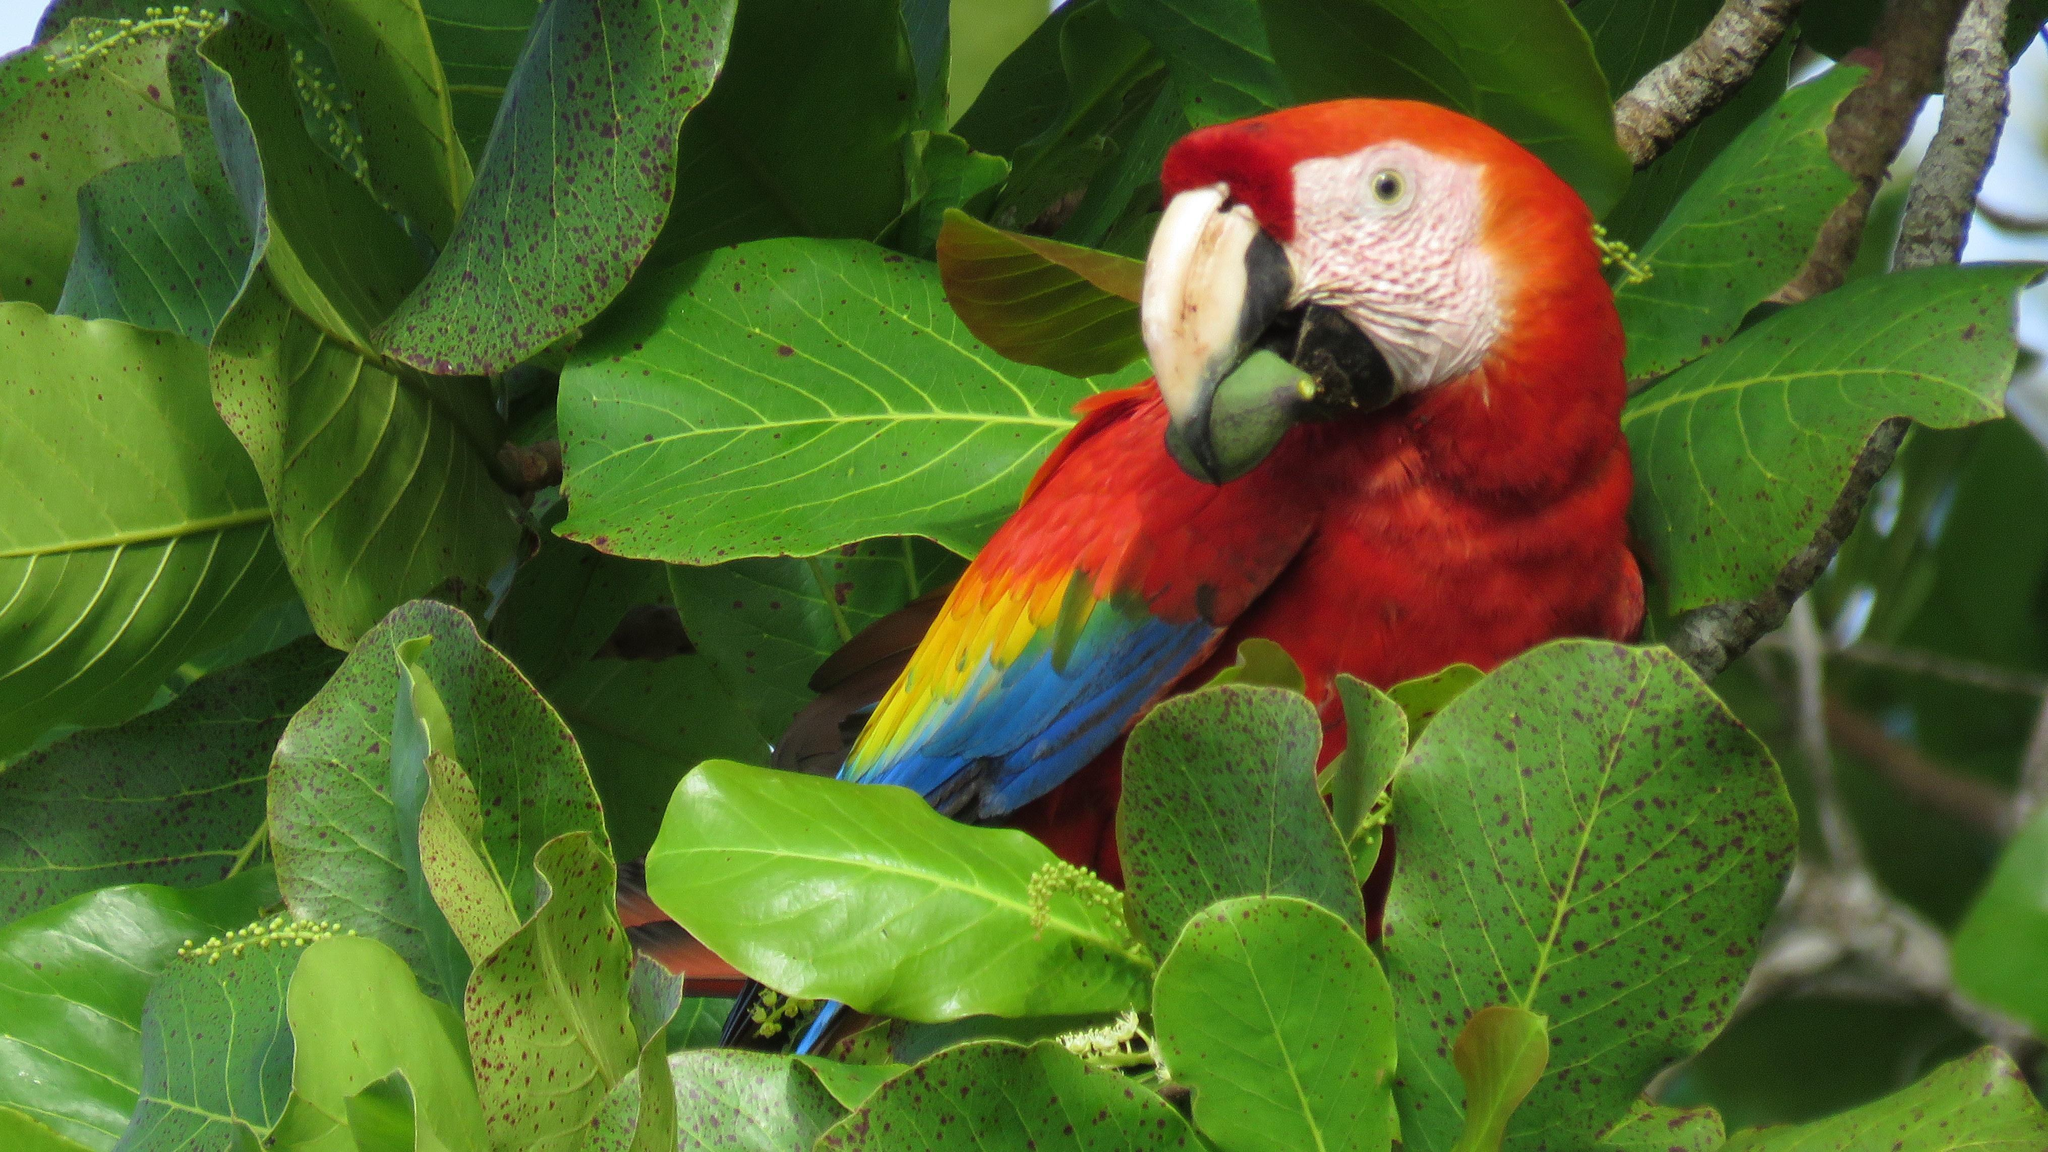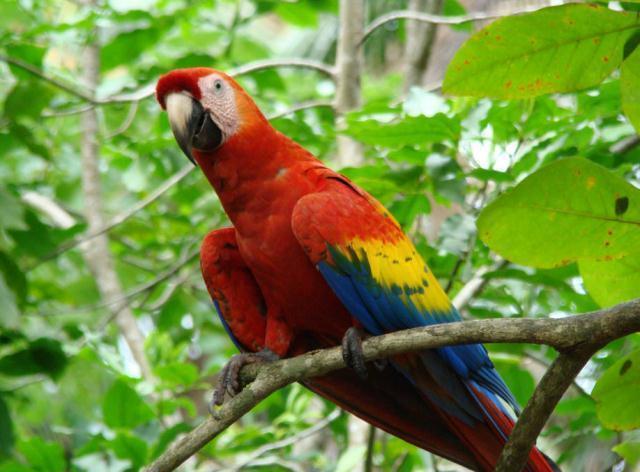The first image is the image on the left, the second image is the image on the right. Considering the images on both sides, is "Each image shows a red-headed bird surrounded by foliage, and in one image, the bird holds a green nut in its beak without using its claw." valid? Answer yes or no. Yes. The first image is the image on the left, the second image is the image on the right. For the images shown, is this caption "A bird looking to the left has something green in its mouth." true? Answer yes or no. Yes. 